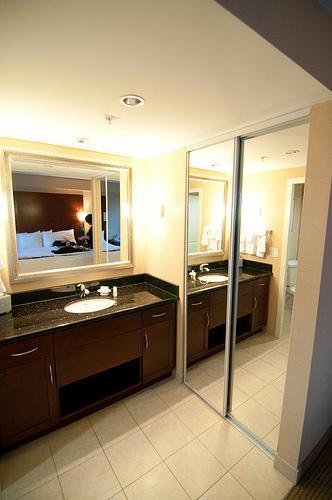How many sinks are shown?
Give a very brief answer. 1. 